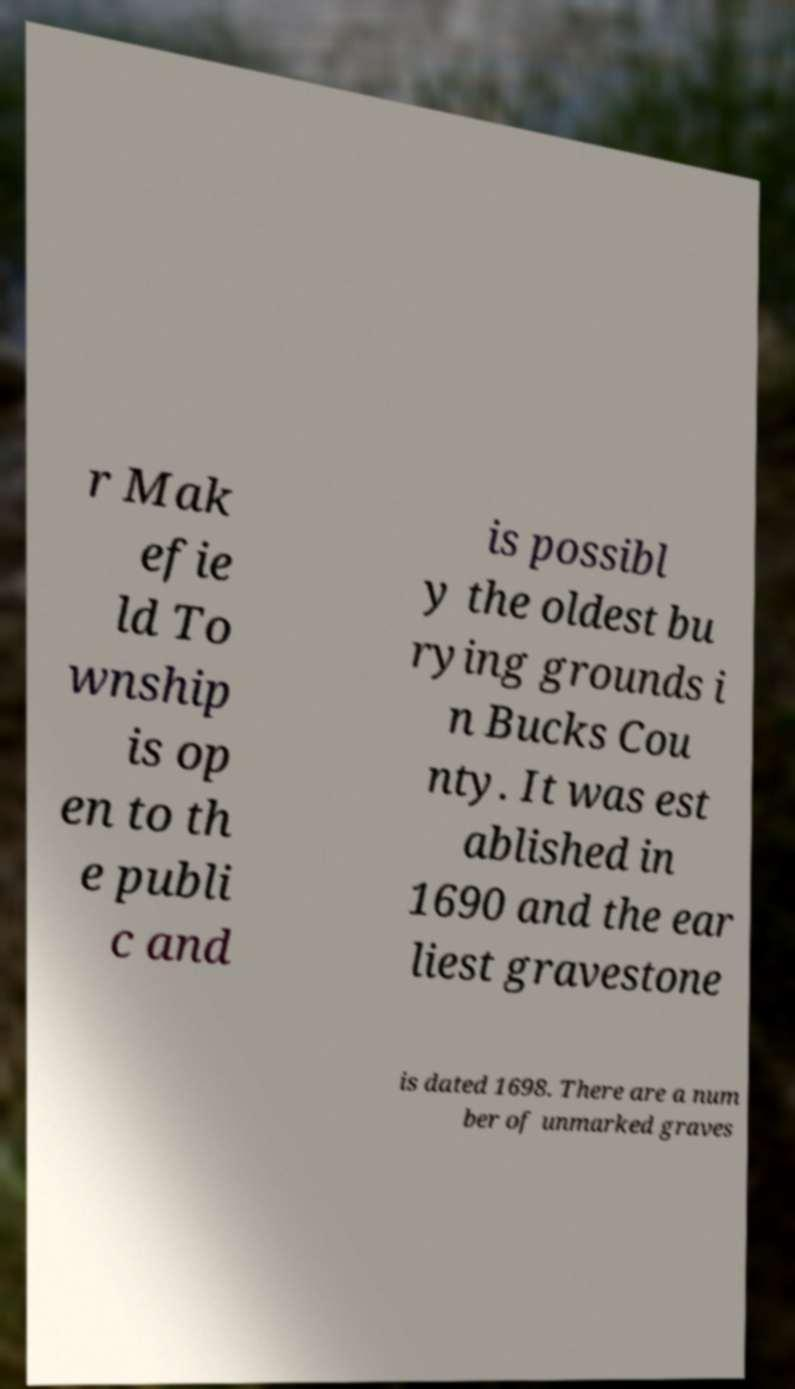Please read and relay the text visible in this image. What does it say? r Mak efie ld To wnship is op en to th e publi c and is possibl y the oldest bu rying grounds i n Bucks Cou nty. It was est ablished in 1690 and the ear liest gravestone is dated 1698. There are a num ber of unmarked graves 